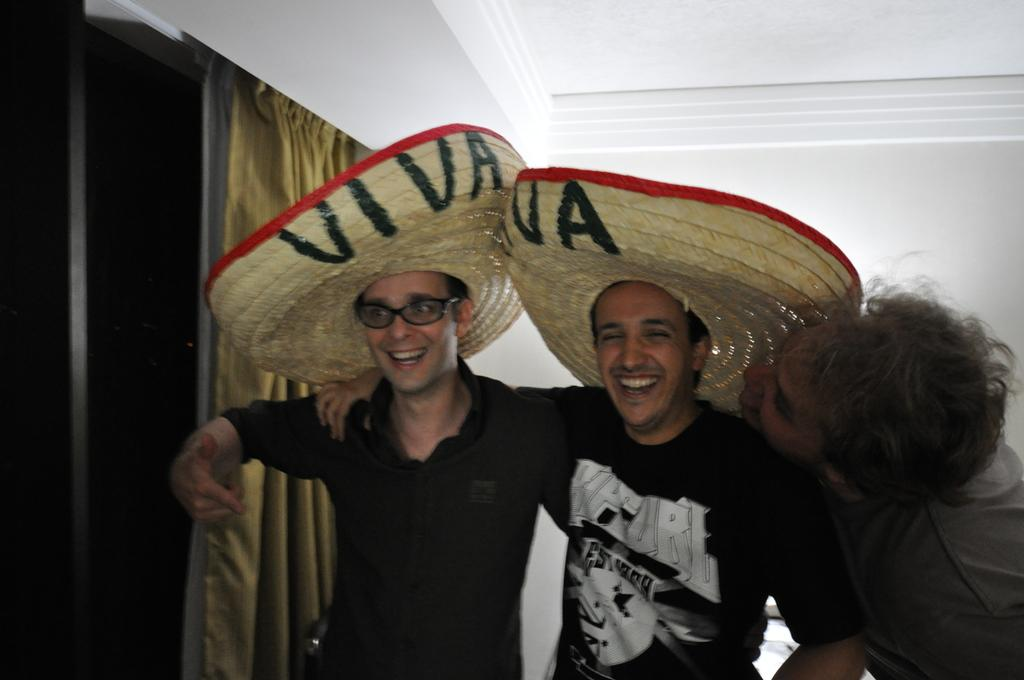How many men are present in the image? There are three men standing in the image. What are two of the men wearing? Two of the men are wearing hats. What can be seen in the background of the image? There is a window with a curtain in the image, as well as a wall and a roof. What type of star can be seen in the image? There is no star present in the image. Are there any ants visible in the image? There are no ants present in the image. 